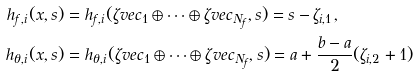Convert formula to latex. <formula><loc_0><loc_0><loc_500><loc_500>h _ { f , i } ( x , s ) & = h _ { f , i } ( \zeta v e c _ { 1 } \oplus \cdots \oplus \zeta v e c _ { N _ { f } } , s ) = s - \zeta _ { i , 1 } , \\ h _ { \theta , i } ( x , s ) & = h _ { \theta , i } ( \zeta v e c _ { 1 } \oplus \cdots \oplus \zeta v e c _ { N _ { f } } , s ) = a + \frac { b - a } { 2 } ( \zeta _ { i , 2 } + 1 )</formula> 